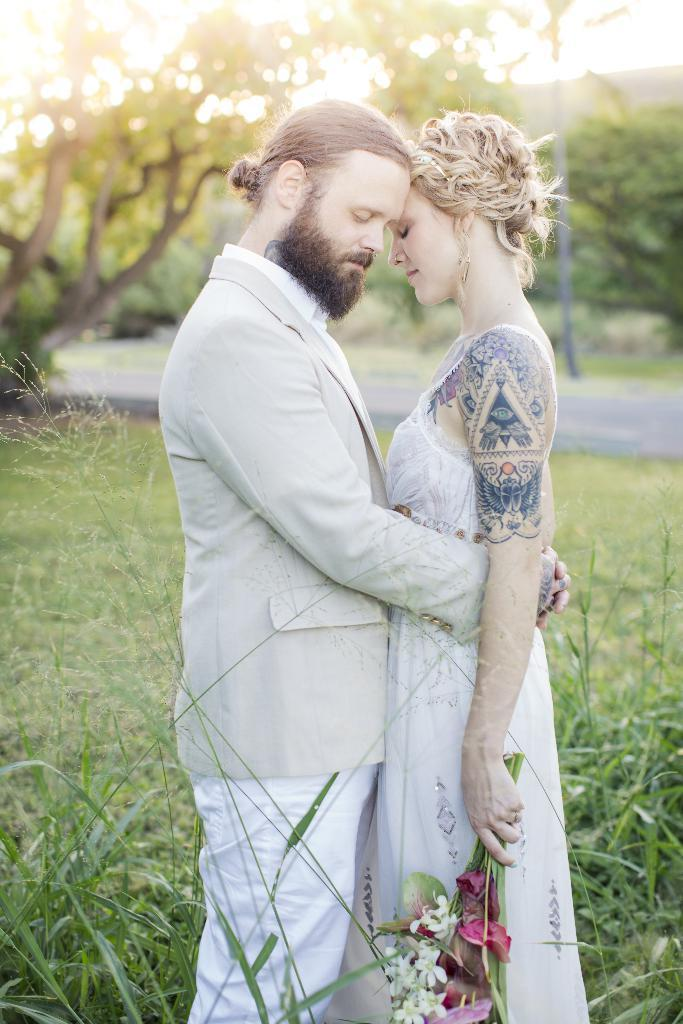How many people are present in the image? There are two people, a man and a woman, present in the image. What is the woman holding in the image? The woman is holding a flower bouquet. What can be seen in the background of the image? There is grass, a pole, a road, and trees in the background of the image. What type of machine is the man operating in the image? There is no machine present in the image; it features a man and a woman with a flower bouquet. What color is the collar on the sweater the woman is wearing in the image? The woman is not wearing a sweater in the image; she is holding a flower bouquet. 